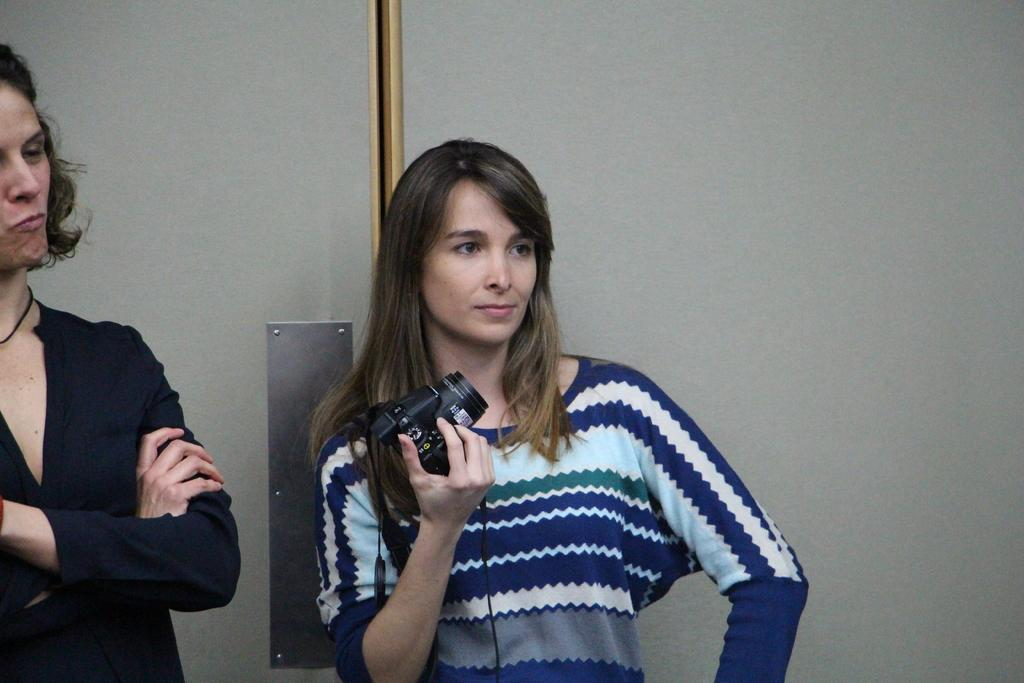How many people are in the image? There are two persons standing in the image. Can you describe the gender of one of the persons? One of the persons is a woman. Where is the woman located in the image? The woman is on the right side of the image. What is the woman holding in her hand? The woman is holding a camera in her hand. What type of coat is the woman wearing in the image? The woman is not wearing a coat in the image; she is holding a camera. Can you describe the garden visible in the image? There is no garden visible in the image. 